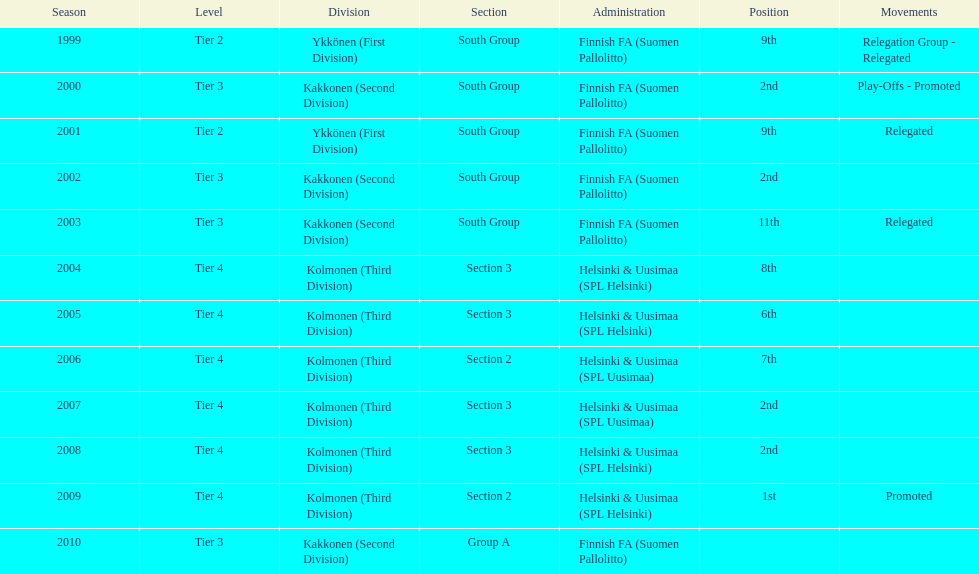How many consecutive times did they play in tier 4? 6. 